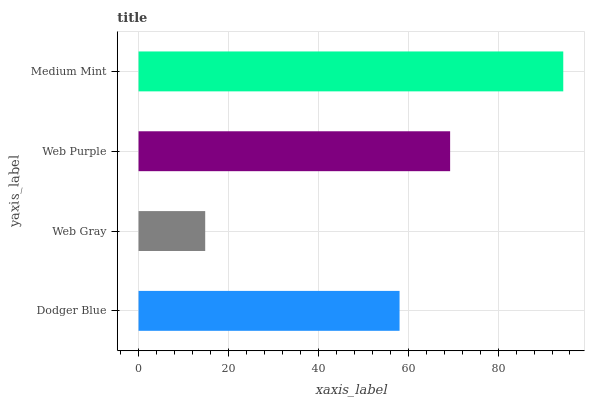Is Web Gray the minimum?
Answer yes or no. Yes. Is Medium Mint the maximum?
Answer yes or no. Yes. Is Web Purple the minimum?
Answer yes or no. No. Is Web Purple the maximum?
Answer yes or no. No. Is Web Purple greater than Web Gray?
Answer yes or no. Yes. Is Web Gray less than Web Purple?
Answer yes or no. Yes. Is Web Gray greater than Web Purple?
Answer yes or no. No. Is Web Purple less than Web Gray?
Answer yes or no. No. Is Web Purple the high median?
Answer yes or no. Yes. Is Dodger Blue the low median?
Answer yes or no. Yes. Is Medium Mint the high median?
Answer yes or no. No. Is Web Purple the low median?
Answer yes or no. No. 